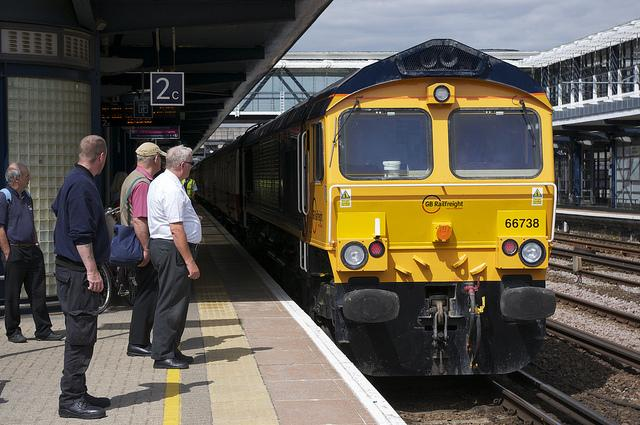Why is there a yellow line on the ground? Please explain your reasoning. safety. Yellow is for caution. 